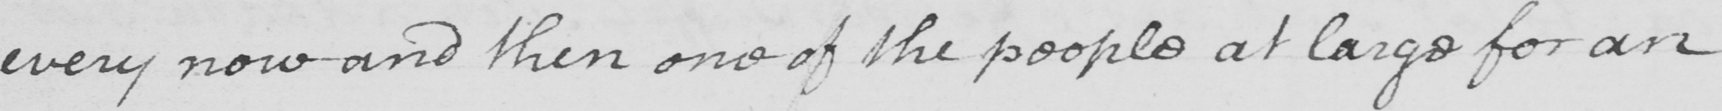Can you tell me what this handwritten text says? every now and then on of the people at large for an 